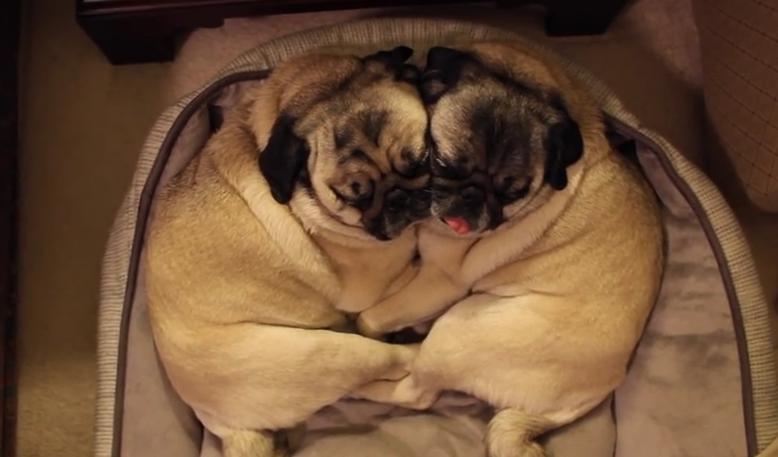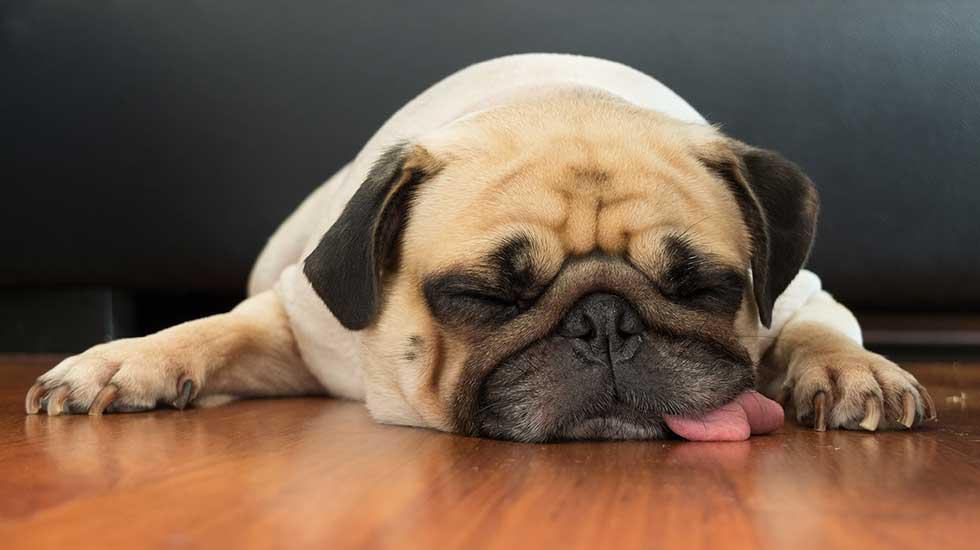The first image is the image on the left, the second image is the image on the right. For the images displayed, is the sentence "a single pug is sleeping with it's tongue sticking out" factually correct? Answer yes or no. Yes. The first image is the image on the left, the second image is the image on the right. Given the left and right images, does the statement "One image shows pugs sleeping side-by-side on something plush, and the other image shows one sleeping pug with its tongue hanging out." hold true? Answer yes or no. Yes. 